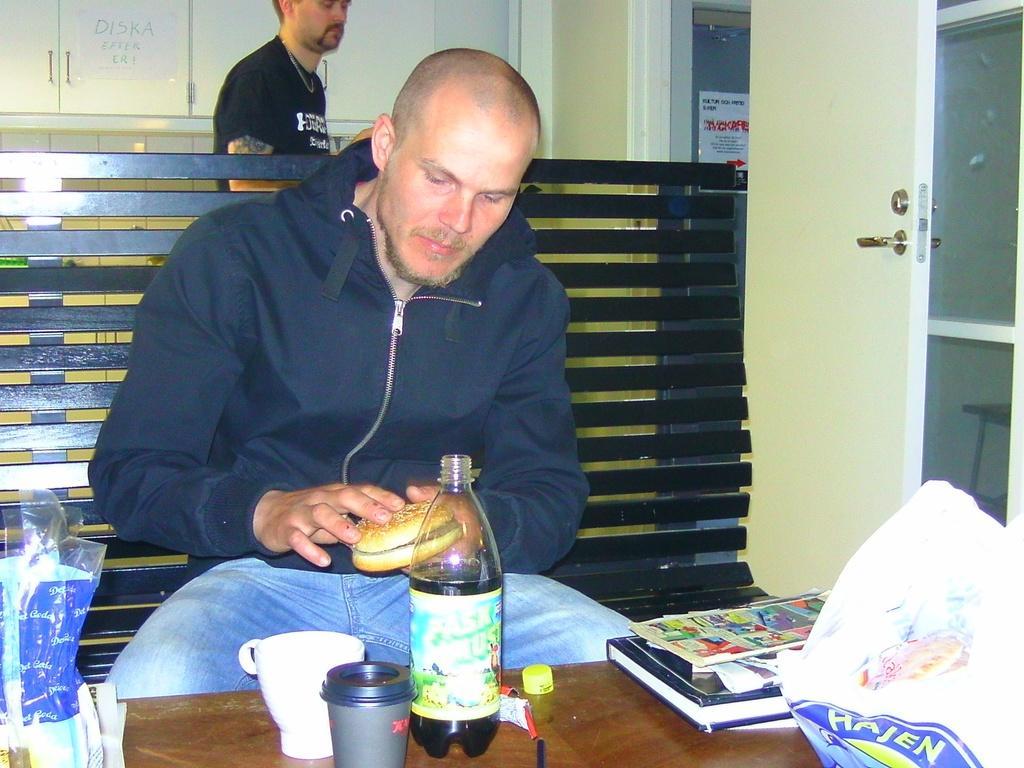How would you summarize this image in a sentence or two? In this image I see a man who is sitting on the bench and he is holding a burger in his hands, I can also see a table on which there are few things. In the background I see another person a door and the wall. 